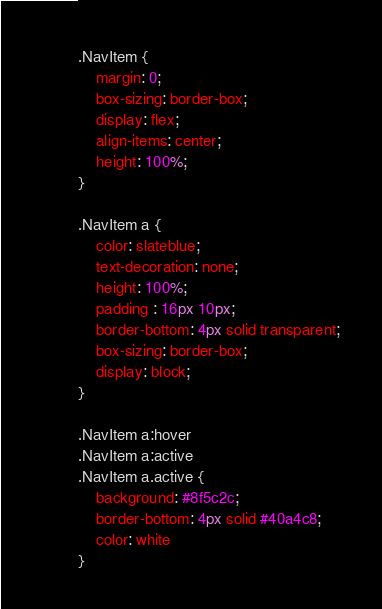<code> <loc_0><loc_0><loc_500><loc_500><_CSS_>.NavItem {
    margin: 0;
    box-sizing: border-box;
    display: flex;
    align-items: center;
    height: 100%;
}

.NavItem a {
    color: slateblue;
    text-decoration: none;
    height: 100%;
    padding : 16px 10px;
    border-bottom: 4px solid transparent;
    box-sizing: border-box;
    display: block;
}

.NavItem a:hover
.NavItem a:active
.NavItem a.active {
    background: #8f5c2c;
    border-bottom: 4px solid #40a4c8;
    color: white
}
</code> 